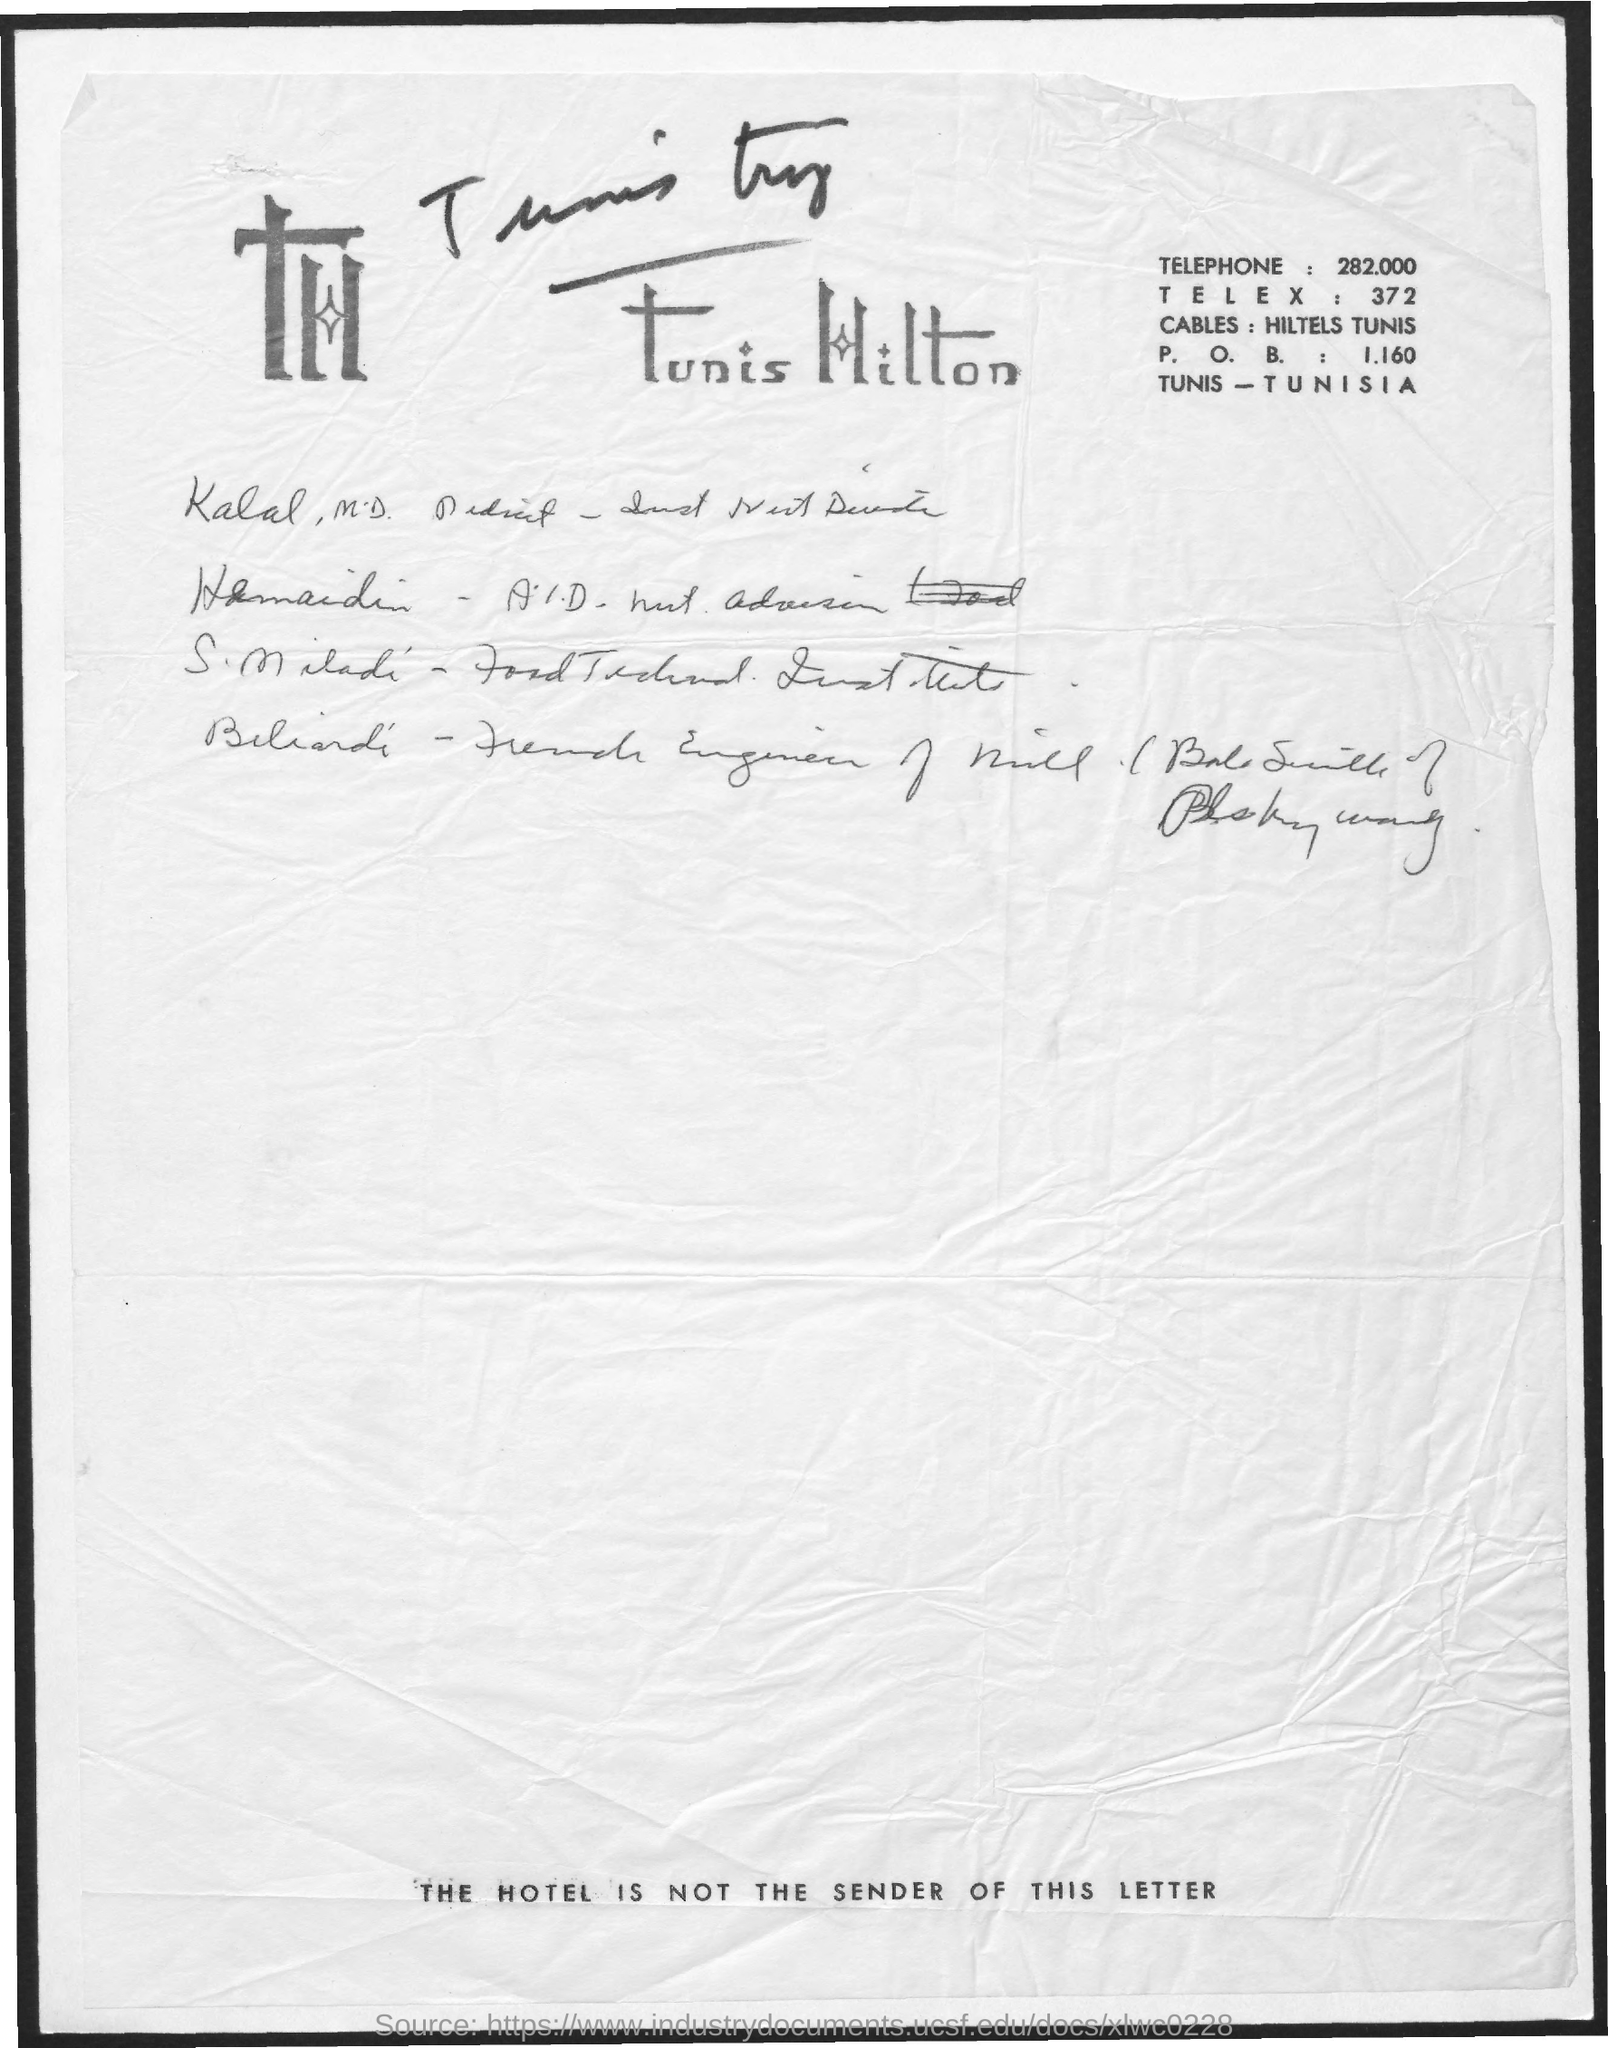Specify some key components in this picture. What is the TELEX? 372..." is a nonsensical string of characters that does not form a grammatically correct sentence. It does not convey a clear or meaningful message. The telephone is a device that allows for communication between two or more people through the use of audio and/or video transmission. What is the P. O. B.? It is a numerical value of 1.160... 